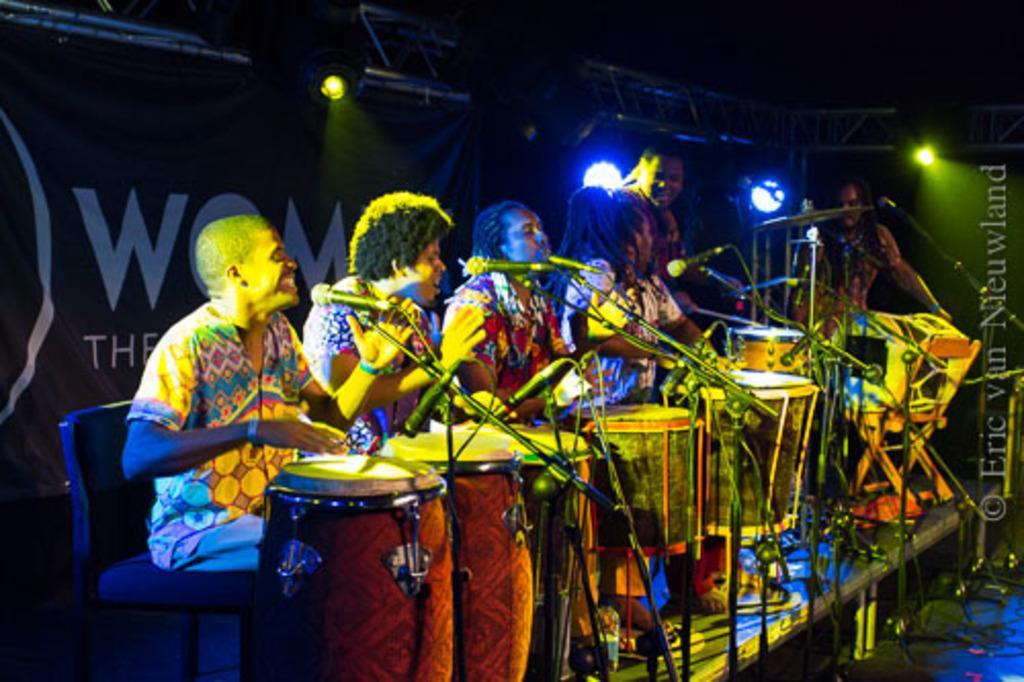Could you give a brief overview of what you see in this image? The image seems to be like it is clicked in a concert. There are six persons in the image. Four of them are sitting and two are standing. All persons are playing drums. In the front there are mic stands along with mics for each of them. In the background there is a banner along with stand and lights. 